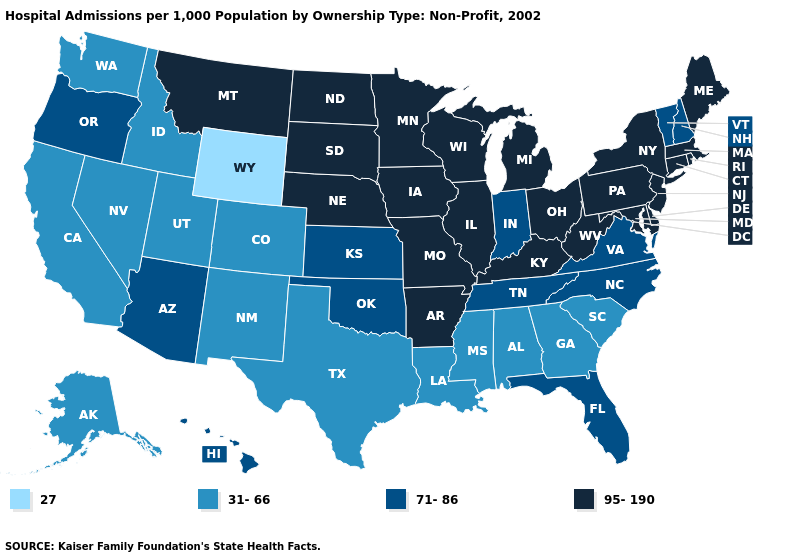Which states have the lowest value in the USA?
Be succinct. Wyoming. Name the states that have a value in the range 27?
Be succinct. Wyoming. What is the value of Minnesota?
Quick response, please. 95-190. Among the states that border Washington , does Oregon have the lowest value?
Write a very short answer. No. Does the map have missing data?
Keep it brief. No. What is the value of Virginia?
Give a very brief answer. 71-86. Name the states that have a value in the range 31-66?
Answer briefly. Alabama, Alaska, California, Colorado, Georgia, Idaho, Louisiana, Mississippi, Nevada, New Mexico, South Carolina, Texas, Utah, Washington. What is the value of New York?
Be succinct. 95-190. Name the states that have a value in the range 95-190?
Keep it brief. Arkansas, Connecticut, Delaware, Illinois, Iowa, Kentucky, Maine, Maryland, Massachusetts, Michigan, Minnesota, Missouri, Montana, Nebraska, New Jersey, New York, North Dakota, Ohio, Pennsylvania, Rhode Island, South Dakota, West Virginia, Wisconsin. Name the states that have a value in the range 95-190?
Answer briefly. Arkansas, Connecticut, Delaware, Illinois, Iowa, Kentucky, Maine, Maryland, Massachusetts, Michigan, Minnesota, Missouri, Montana, Nebraska, New Jersey, New York, North Dakota, Ohio, Pennsylvania, Rhode Island, South Dakota, West Virginia, Wisconsin. Among the states that border Tennessee , does Mississippi have the lowest value?
Short answer required. Yes. Name the states that have a value in the range 71-86?
Quick response, please. Arizona, Florida, Hawaii, Indiana, Kansas, New Hampshire, North Carolina, Oklahoma, Oregon, Tennessee, Vermont, Virginia. What is the value of Washington?
Be succinct. 31-66. Does the first symbol in the legend represent the smallest category?
Concise answer only. Yes. 